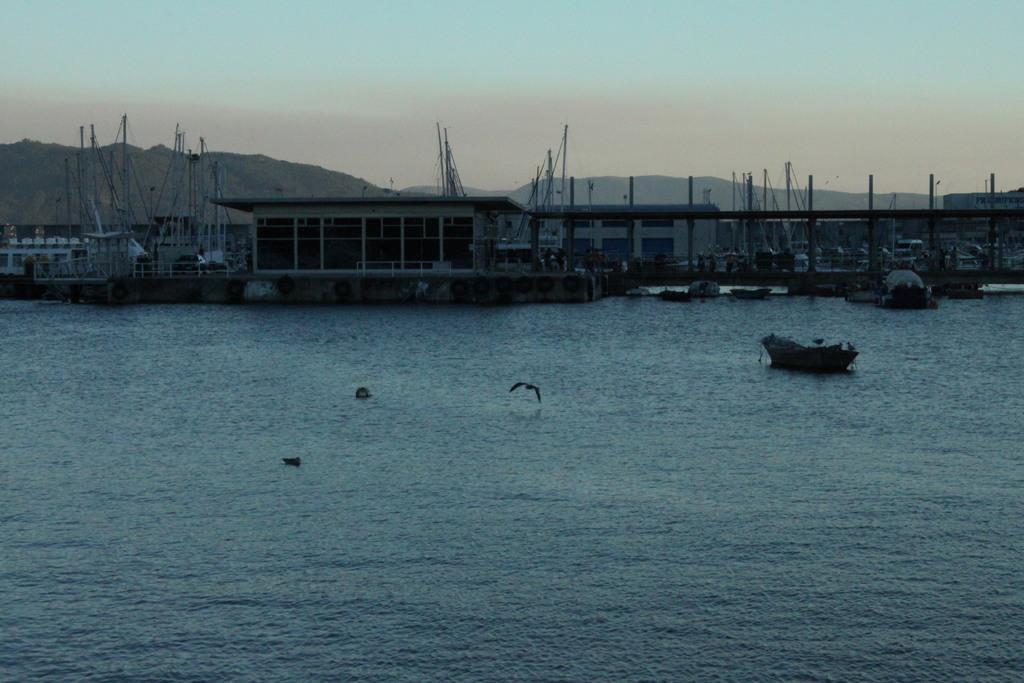Please provide a concise description of this image. In this picture I see the water in front and in the center of this picture I see a bird and in the background I see few buildings, number of boards, mountains and the sky. 